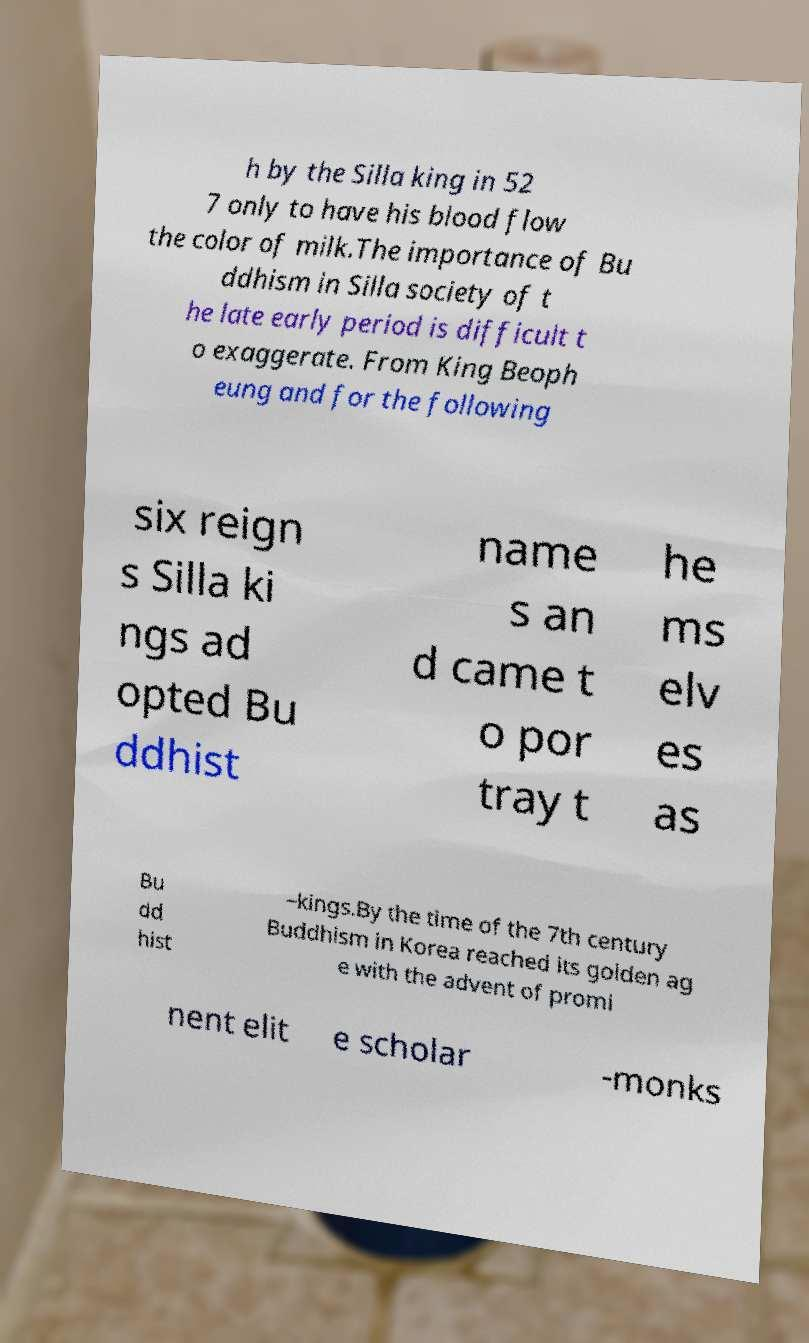There's text embedded in this image that I need extracted. Can you transcribe it verbatim? h by the Silla king in 52 7 only to have his blood flow the color of milk.The importance of Bu ddhism in Silla society of t he late early period is difficult t o exaggerate. From King Beoph eung and for the following six reign s Silla ki ngs ad opted Bu ddhist name s an d came t o por tray t he ms elv es as Bu dd hist –kings.By the time of the 7th century Buddhism in Korea reached its golden ag e with the advent of promi nent elit e scholar -monks 